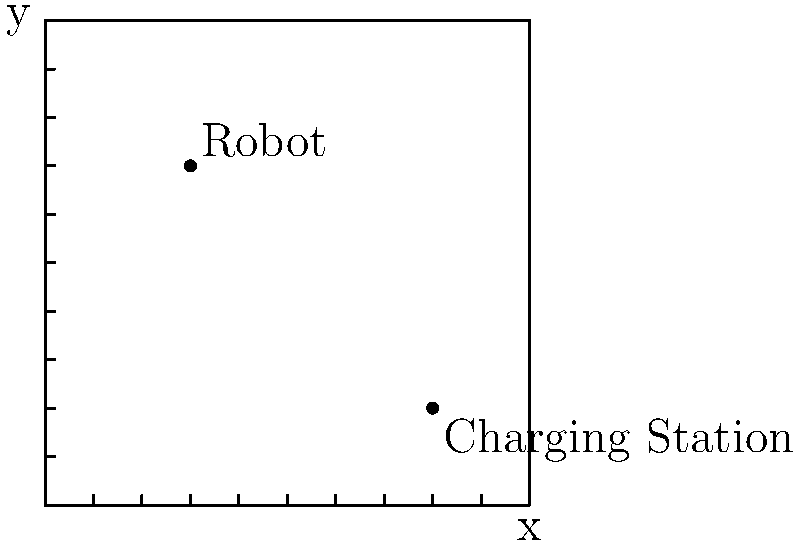In your square-shaped playroom, there's a robot and its charging station. The room is 10 units wide and 10 units tall. If the robot is at coordinates (3,7), and it needs to move in a straight line to its charging station at (8,2), how far does the robot need to travel? Let's solve this step-by-step:

1) We have two points:
   Robot: $(x_1, y_1) = (3, 7)$
   Charging Station: $(x_2, y_2) = (8, 2)$

2) To find the distance between these points, we can use the distance formula:
   $d = \sqrt{(x_2 - x_1)^2 + (y_2 - y_1)^2}$

3) Let's substitute our values:
   $d = \sqrt{(8 - 3)^2 + (2 - 7)^2}$

4) Simplify inside the parentheses:
   $d = \sqrt{5^2 + (-5)^2}$

5) Calculate the squares:
   $d = \sqrt{25 + 25}$

6) Add under the square root:
   $d = \sqrt{50}$

7) Simplify the square root:
   $d = 5\sqrt{2}$

So, the robot needs to travel $5\sqrt{2}$ units to reach its charging station.
Answer: $5\sqrt{2}$ units 